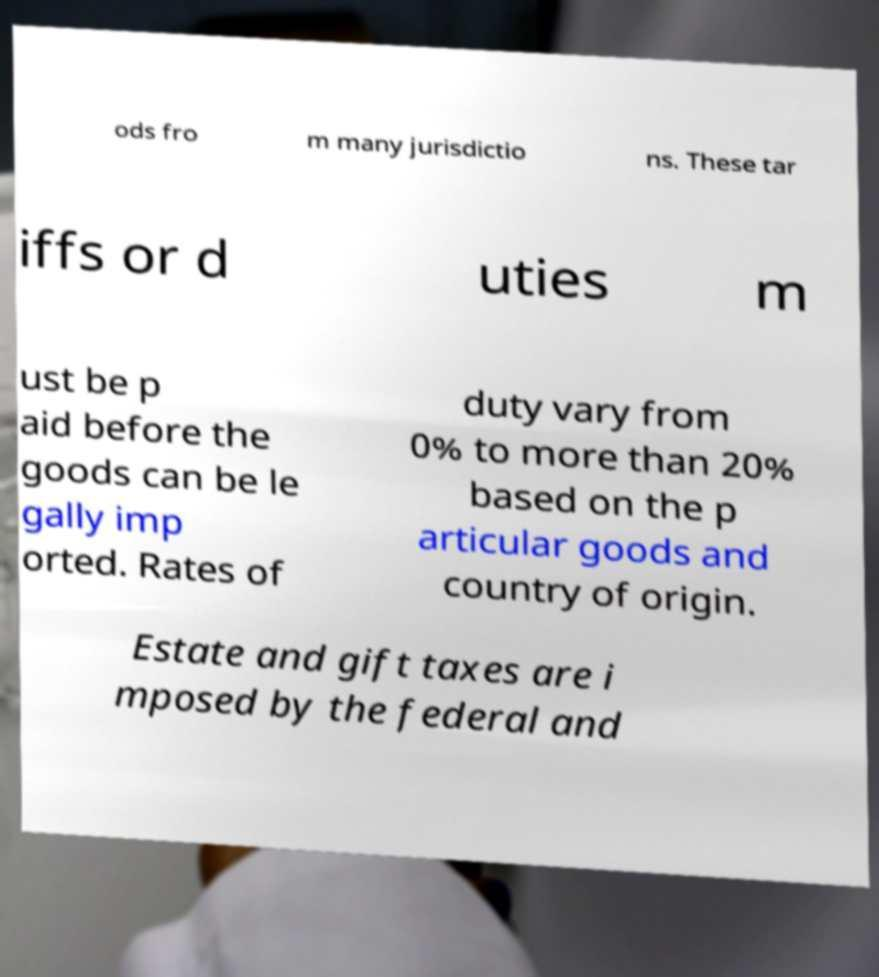Please read and relay the text visible in this image. What does it say? ods fro m many jurisdictio ns. These tar iffs or d uties m ust be p aid before the goods can be le gally imp orted. Rates of duty vary from 0% to more than 20% based on the p articular goods and country of origin. Estate and gift taxes are i mposed by the federal and 